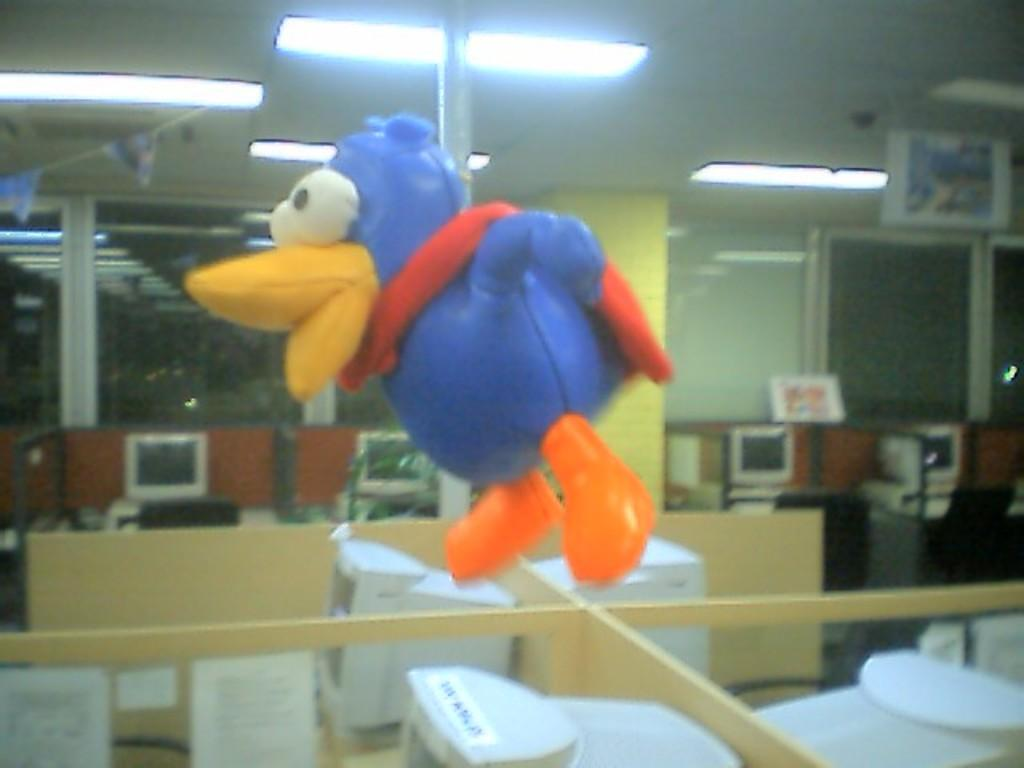What type of object can be seen in the image that is typically used for recreational purposes? There is an inflatable toy in the image. What electronic devices are visible in the image? There are computers in the image. What type of illumination is present in the image? There are lights in the image. What architectural feature can be seen in the image? There are pillars in the image. Can you tell me how many experts are present in the image? There is no mention of experts in the image; it features an inflatable toy, computers, lights, and pillars. What time of day is depicted in the image? The time of day is not discernible from the image; it only shows an inflatable toy, computers, lights, and pillars. 